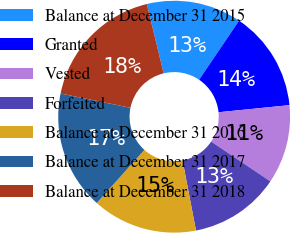<chart> <loc_0><loc_0><loc_500><loc_500><pie_chart><fcel>Balance at December 31 2015<fcel>Granted<fcel>Vested<fcel>Forfeited<fcel>Balance at December 31 2016<fcel>Balance at December 31 2017<fcel>Balance at December 31 2018<nl><fcel>13.25%<fcel>13.95%<fcel>11.01%<fcel>12.56%<fcel>14.65%<fcel>16.57%<fcel>18.01%<nl></chart> 